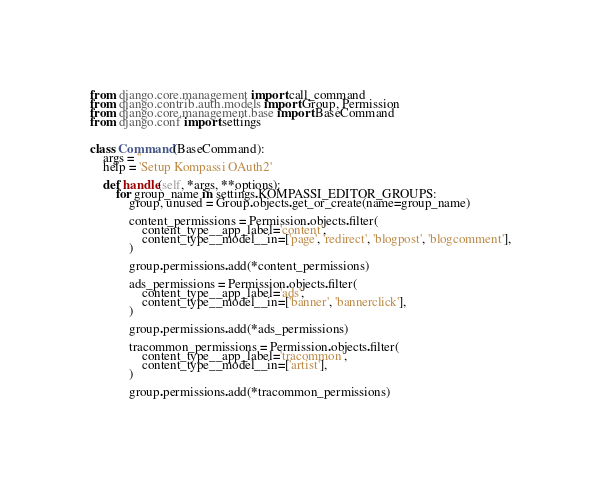<code> <loc_0><loc_0><loc_500><loc_500><_Python_>from django.core.management import call_command
from django.contrib.auth.models import Group, Permission
from django.core.management.base import BaseCommand
from django.conf import settings


class Command(BaseCommand):
    args = ''
    help = 'Setup Kompassi OAuth2'

    def handle(self, *args, **options):
        for group_name in settings.KOMPASSI_EDITOR_GROUPS:
            group, unused = Group.objects.get_or_create(name=group_name)

            content_permissions = Permission.objects.filter(
                content_type__app_label='content',
                content_type__model__in=['page', 'redirect', 'blogpost', 'blogcomment'],
            )

            group.permissions.add(*content_permissions)

            ads_permissions = Permission.objects.filter(
                content_type__app_label='ads',
                content_type__model__in=['banner', 'bannerclick'],
            )

            group.permissions.add(*ads_permissions)

            tracommon_permissions = Permission.objects.filter(
                content_type__app_label='tracommon',
                content_type__model__in=['artist'],
            )

            group.permissions.add(*tracommon_permissions)
</code> 